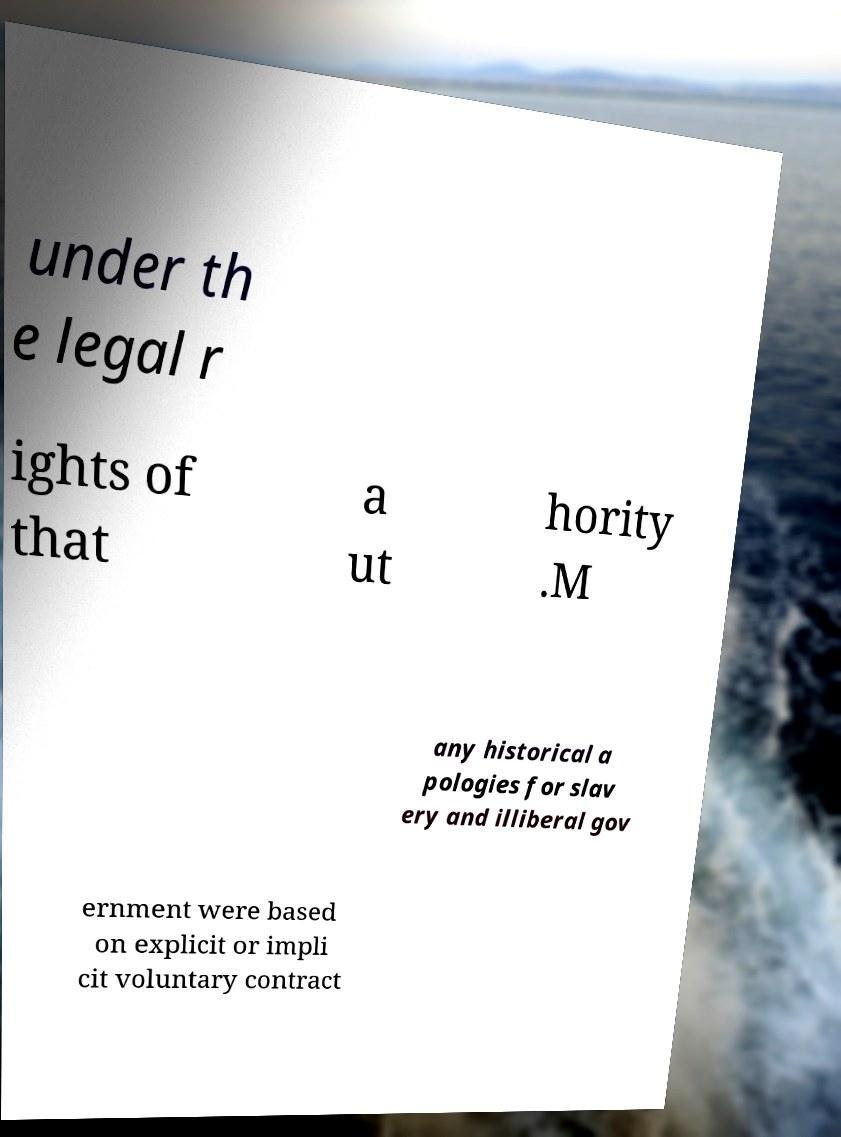Could you assist in decoding the text presented in this image and type it out clearly? under th e legal r ights of that a ut hority .M any historical a pologies for slav ery and illiberal gov ernment were based on explicit or impli cit voluntary contract 